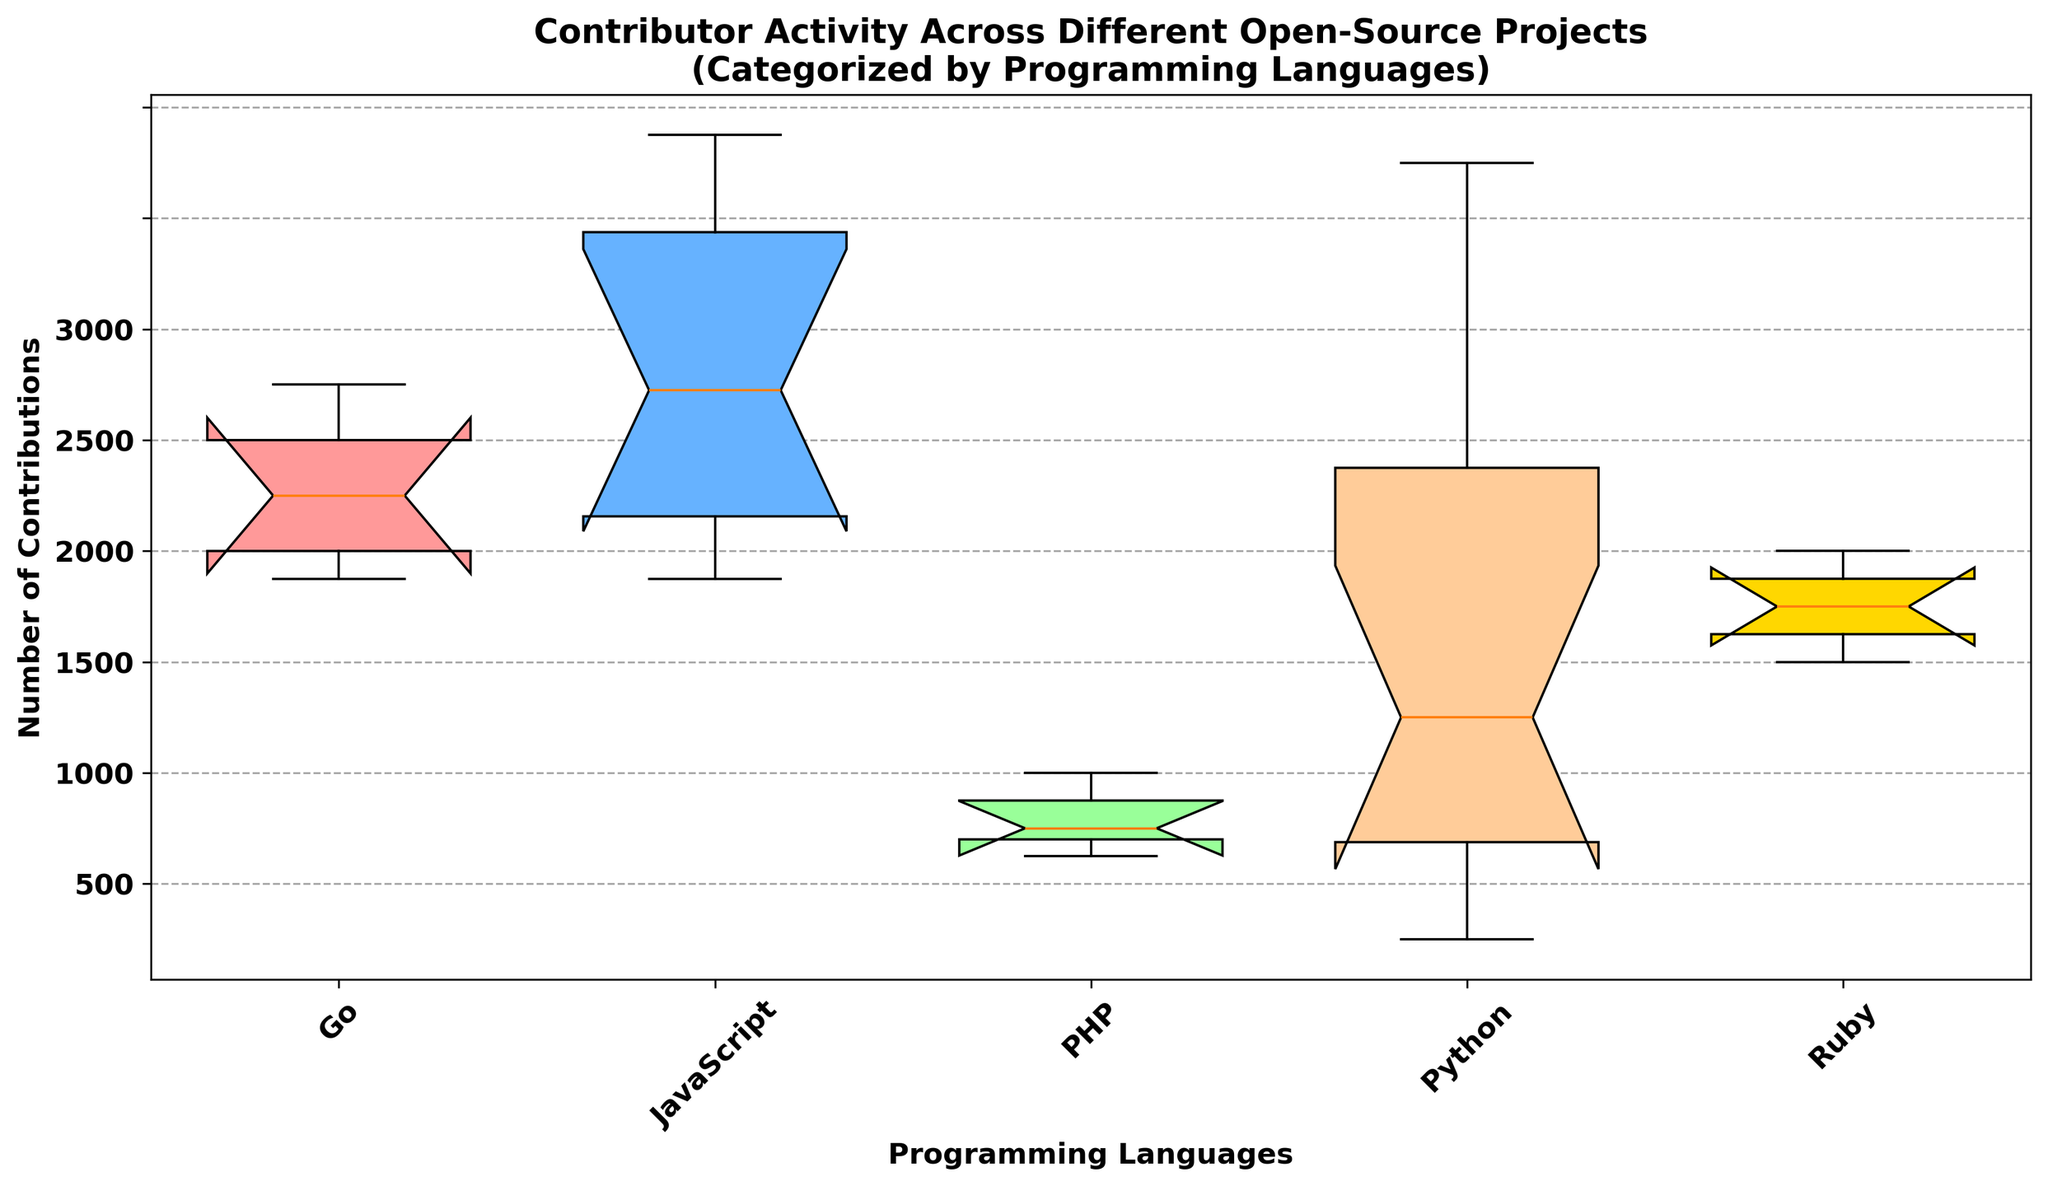What is the median number of contributions for JavaScript projects? To find the median, look at the central tendency line inside the box for JavaScript projects on the x-axis corresponding to React and Vue. For JavaScript, locate and divide the box showing contributions for React and Vue projects. Identify the median line within these boxes; React appears higher than Vue.
Answer: Median contributions for JavaScript are different for two projects: React has ~2400 and Vue has ~1850 Which programming language has the highest contributor activity? To determine the highest contributor activity, locate the boxes with the highest medians. Visual inspection reveals that React (JavaScript) has a higher median compared to other languages. Thus, JavaScript appears to have the highest activity, particularly for the React project.
Answer: JavaScript (React) Between Go and PHP, which programming language has higher contributor activity, and by how much? Compare the medians of the boxes representing Go (Kubernetes) and PHP (Laravel). The median is visually represented by the line inside the boxes. Kubernetes' (Go) median appears to be higher than Laravel’s (PHP). Subtract Laravel's median (~1300) from Kubernetes' (~1900).
Answer: Go is higher by ~600 contributions What is the interquartile range (IQR) for the Python projects? Calculate the IQR by determining the ranges between the 25th percentile (bottom of the box) and the 75th percentile (top of the box). For Python projects, assess TensorFlow, Django, and Flask. Look at the vertical distance between the bottom and the top edges of the boxes. For example, TensorFlow ranges between ~2000 and ~2400, giving an IQR of (2400-2000) = 400. Do this calculation for all Python projects.
Answer: TensorFlow ~400, Django ~200, Flask ~150 Which project has the most variability in contributions and which has the least? Variability is indicated by the length of the whiskers and the spread of the box (IQR). Identify the project with the longest whiskers and largest box for most variability and the smallest for the least. React (JavaScript) has the most variability with a broad box and long whiskers. Flask (Python) or Django (Python) exhibit the least variability with shorter whiskers and smaller boxes.
Answer: Most: React; Least: Flask or Django How do the middle 50% of contributions for Ruby projects compare to PHP projects? The middle 50% of contributions is represented by the box (IQR). Compare the height of the boxes for Ruby (Rails) and PHP (Laravel). Ruby’s box for Rails appears higher and slightly wider than PHP's Laravel, suggesting that Ruby projects have higher and more spread out contributions.
Answer: Ruby’s median and IQR are both higher What is the range of contributions for the Vue project (JavaScript)? The range is found by identifying the smallest (bottom whisker) and largest (top whisker) values in the Vue box plot. Vue’s whiskers range from ~1750 to ~1980.
Answer: ~230 contributions (1980-1750) Which project has the highest top whisker? The top whisker represents the maximum value. Locate the uppermost whisker among the plots. This is found in the React (JavaScript) project, which extends the highest.
Answer: React 